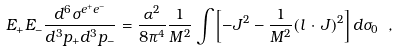Convert formula to latex. <formula><loc_0><loc_0><loc_500><loc_500>E _ { + } E _ { - } \frac { d ^ { 6 } \sigma ^ { e ^ { + } e ^ { - } } } { d ^ { 3 } p _ { + } d ^ { 3 } p _ { - } } = \frac { \alpha ^ { 2 } } { 8 \pi ^ { 4 } } \frac { 1 } { M ^ { 2 } } \int \left [ - J ^ { 2 } - \frac { 1 } { M ^ { 2 } } ( l \, \cdot \, J ) ^ { 2 } \right ] d \sigma _ { 0 } \ ,</formula> 